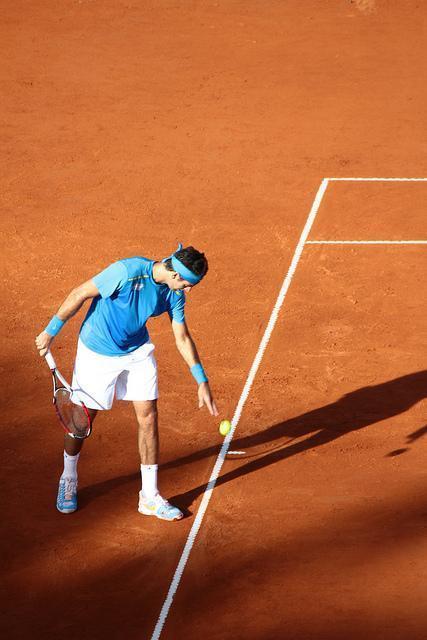How many tennis rackets are there?
Give a very brief answer. 1. 